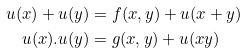Convert formula to latex. <formula><loc_0><loc_0><loc_500><loc_500>u ( x ) + u ( y ) & = f ( x , y ) + u ( x + y ) \\ u ( x ) . u ( y ) & = g ( x , y ) + u ( x y )</formula> 